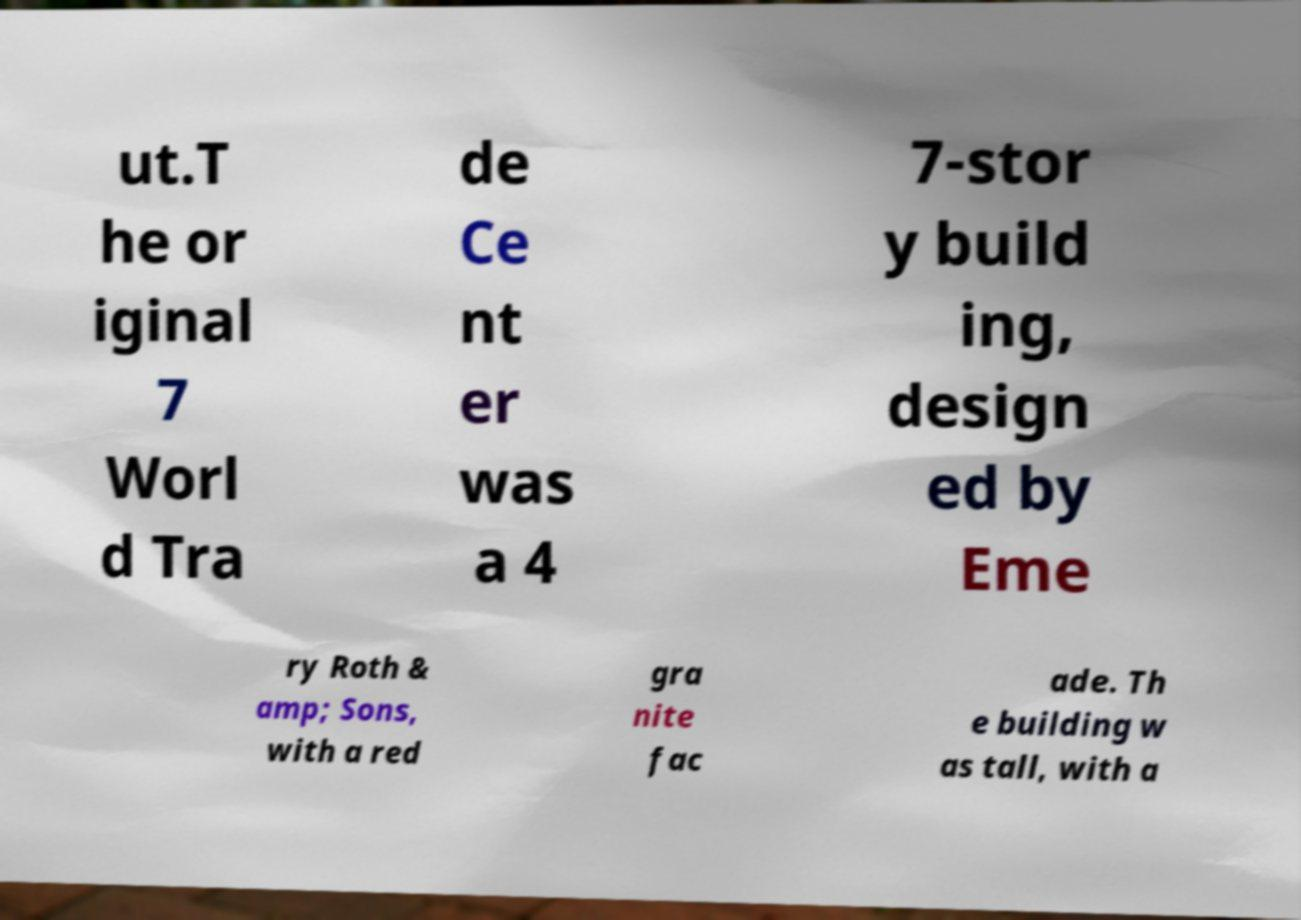For documentation purposes, I need the text within this image transcribed. Could you provide that? ut.T he or iginal 7 Worl d Tra de Ce nt er was a 4 7-stor y build ing, design ed by Eme ry Roth & amp; Sons, with a red gra nite fac ade. Th e building w as tall, with a 